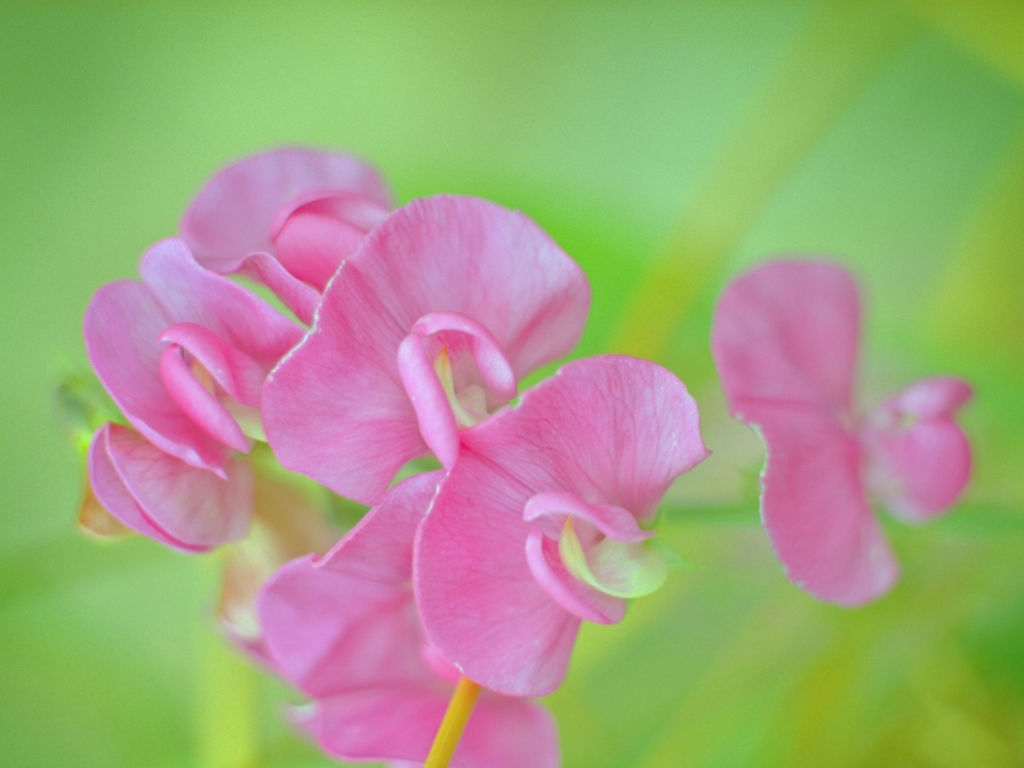Is the composition visually pleasing? The composition displays a delicate balance of color with the soft pink petals standing out against the vibrant green background, creating a visually pleasing image that exudes tranquility and a subtle elegance. 